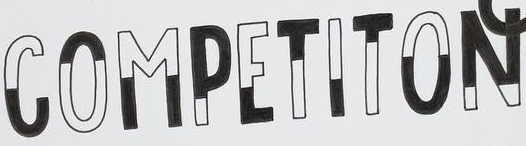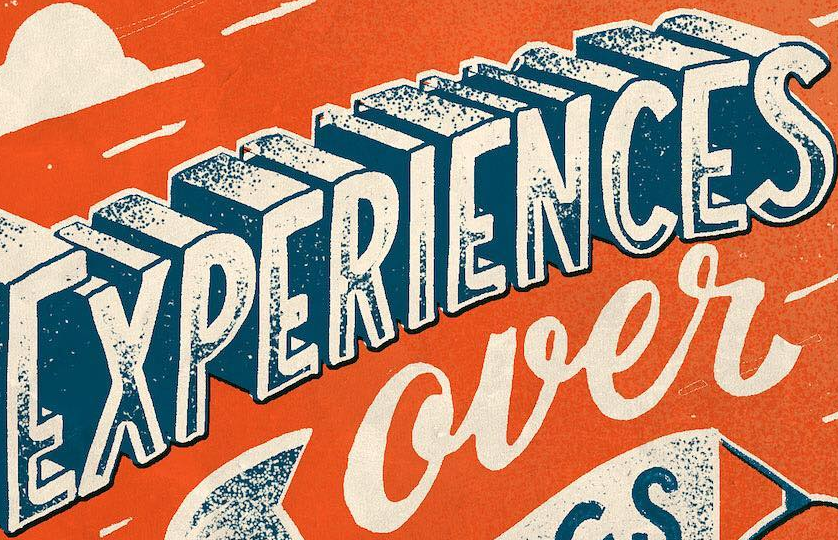Transcribe the words shown in these images in order, separated by a semicolon. COMPETITON; EXPERIENCES 